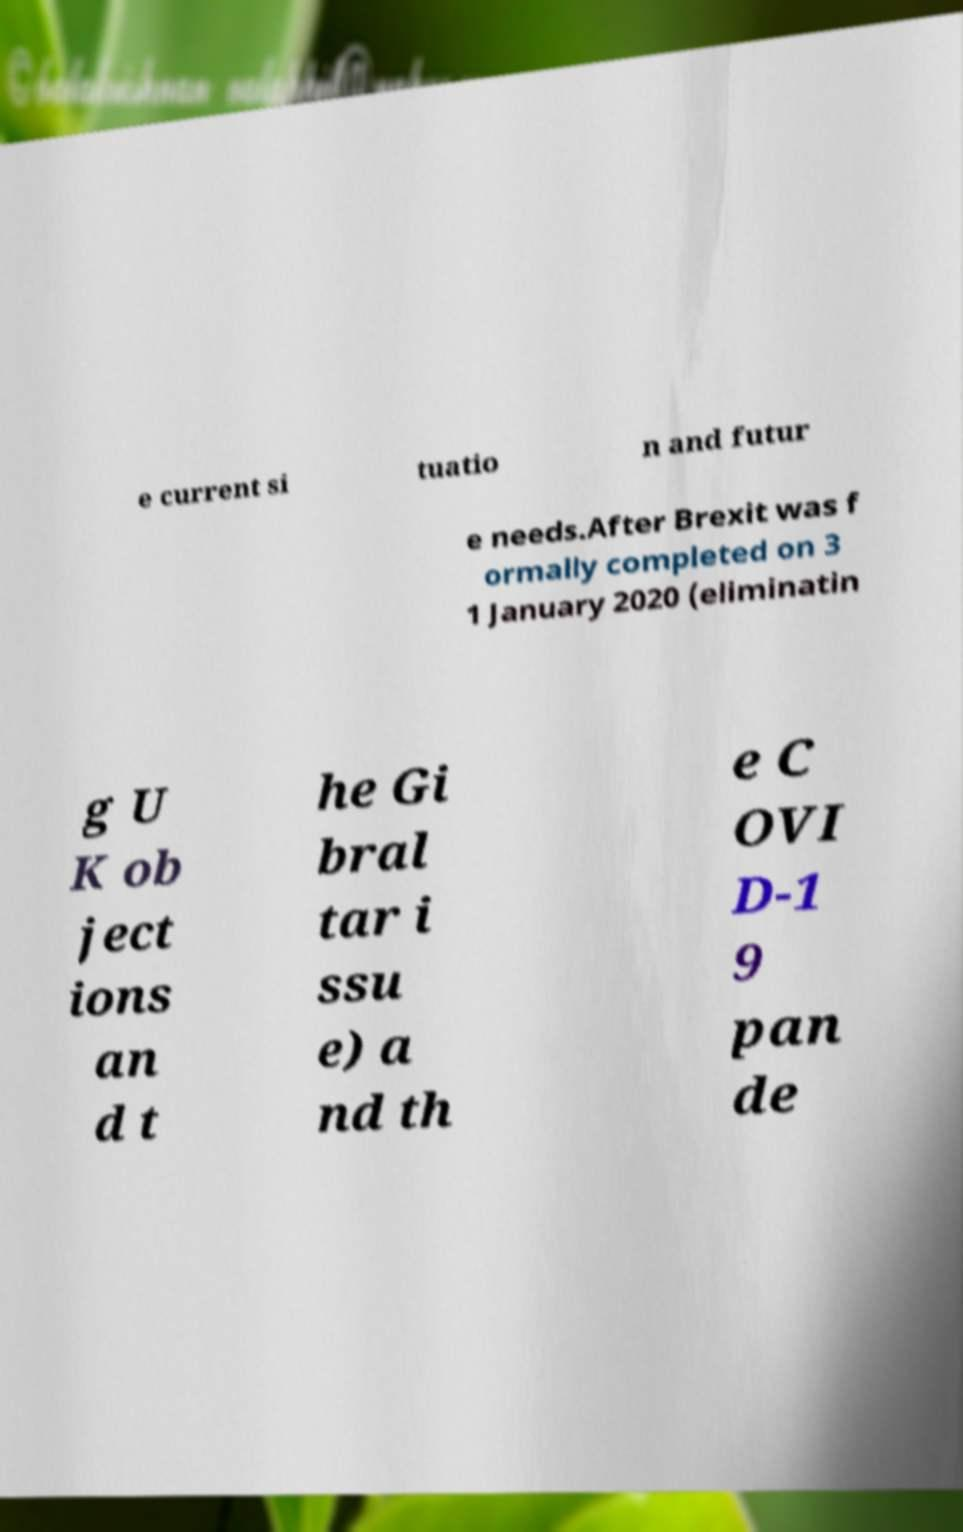Can you read and provide the text displayed in the image?This photo seems to have some interesting text. Can you extract and type it out for me? e current si tuatio n and futur e needs.After Brexit was f ormally completed on 3 1 January 2020 (eliminatin g U K ob ject ions an d t he Gi bral tar i ssu e) a nd th e C OVI D-1 9 pan de 